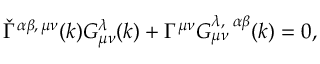Convert formula to latex. <formula><loc_0><loc_0><loc_500><loc_500>\check { \Gamma } ^ { \alpha \beta , \, \mu \nu } ( k ) G _ { \mu \nu } ^ { \lambda } ( k ) + \Gamma ^ { \mu \nu } G _ { \mu \nu } ^ { \lambda , \, \alpha \beta } ( k ) = 0 ,</formula> 